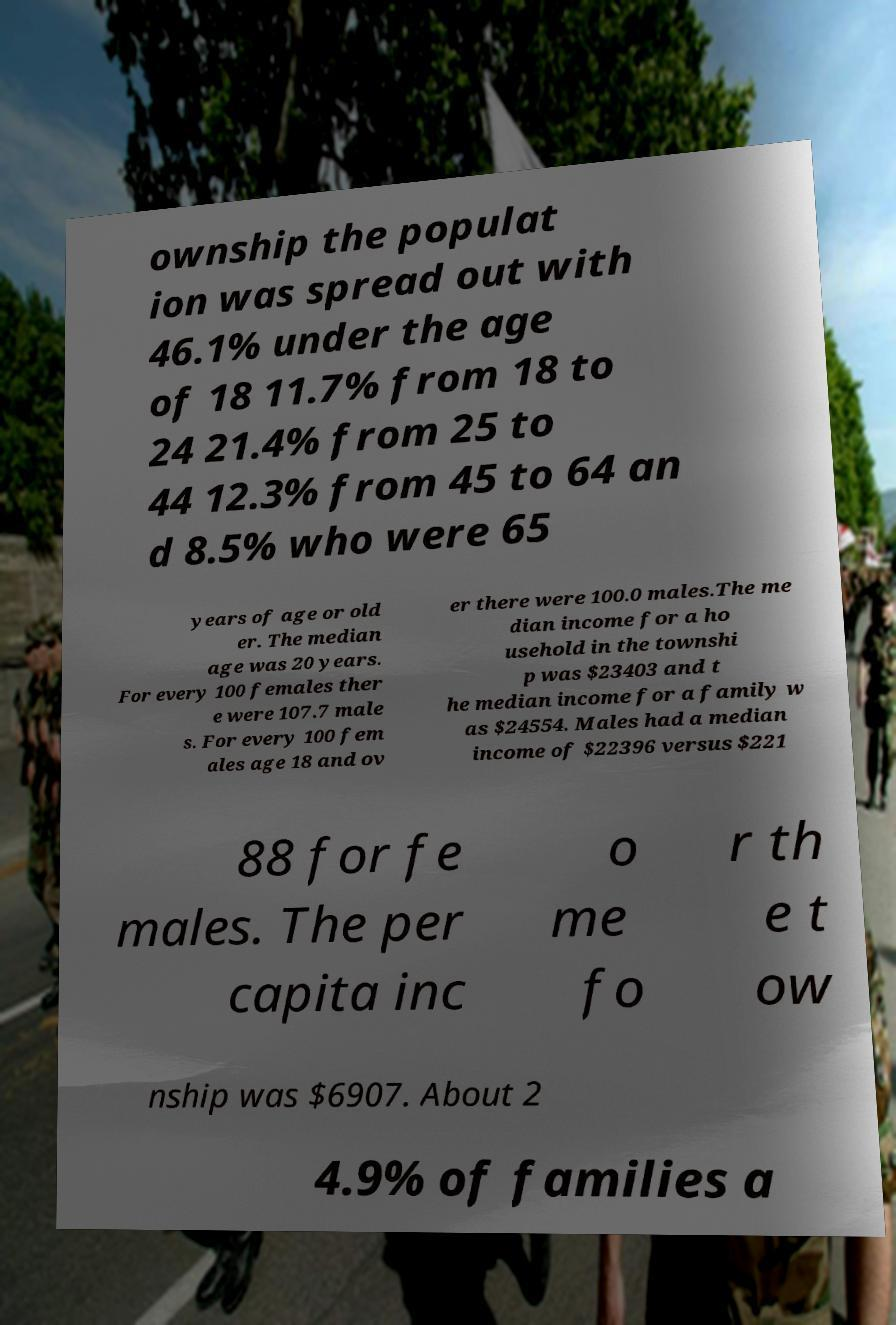There's text embedded in this image that I need extracted. Can you transcribe it verbatim? ownship the populat ion was spread out with 46.1% under the age of 18 11.7% from 18 to 24 21.4% from 25 to 44 12.3% from 45 to 64 an d 8.5% who were 65 years of age or old er. The median age was 20 years. For every 100 females ther e were 107.7 male s. For every 100 fem ales age 18 and ov er there were 100.0 males.The me dian income for a ho usehold in the townshi p was $23403 and t he median income for a family w as $24554. Males had a median income of $22396 versus $221 88 for fe males. The per capita inc o me fo r th e t ow nship was $6907. About 2 4.9% of families a 